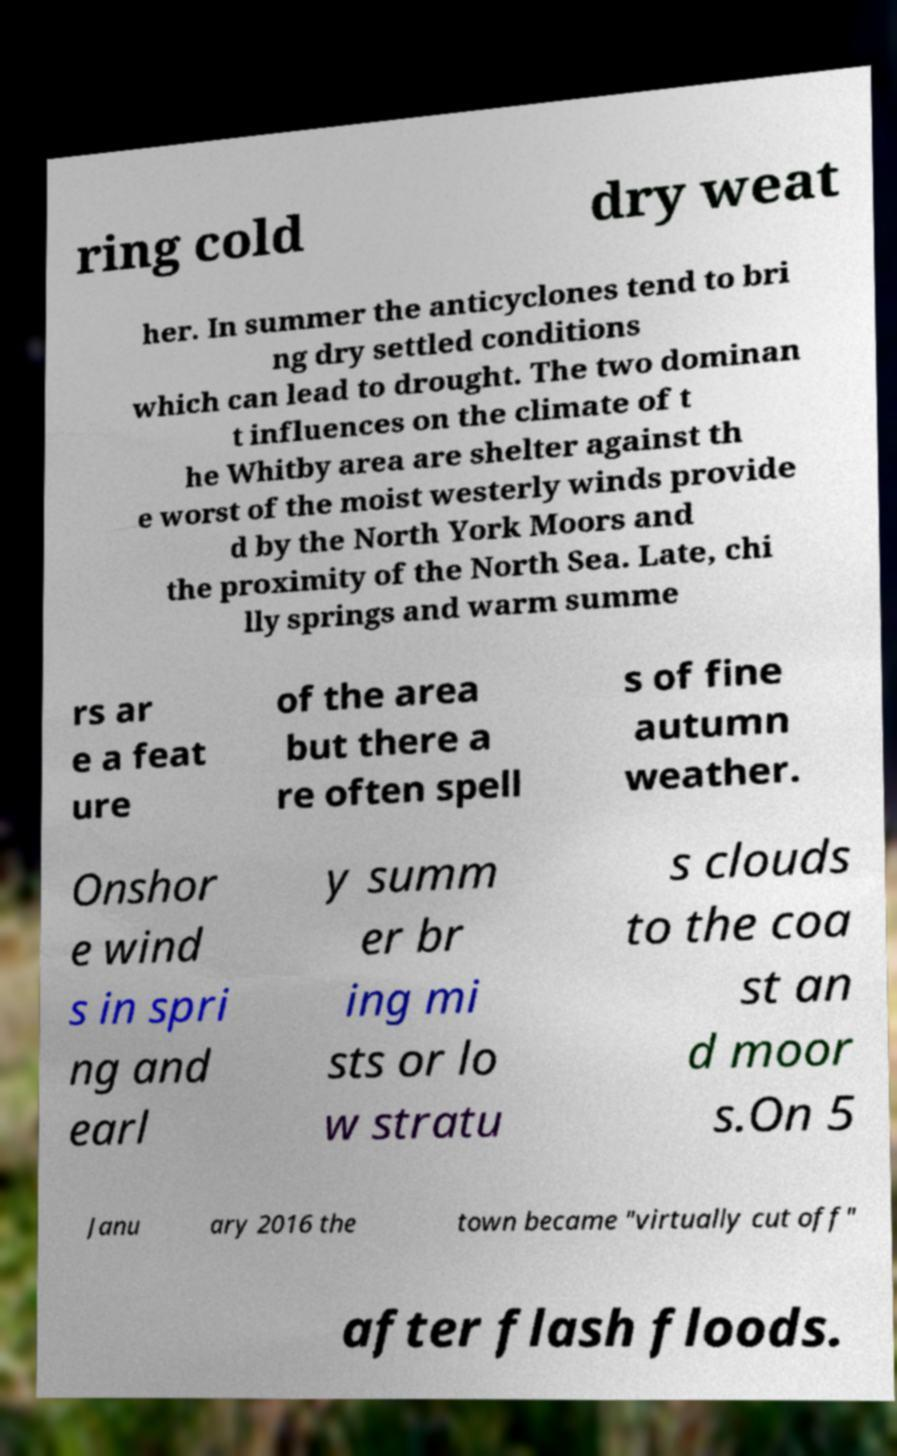I need the written content from this picture converted into text. Can you do that? ring cold dry weat her. In summer the anticyclones tend to bri ng dry settled conditions which can lead to drought. The two dominan t influences on the climate of t he Whitby area are shelter against th e worst of the moist westerly winds provide d by the North York Moors and the proximity of the North Sea. Late, chi lly springs and warm summe rs ar e a feat ure of the area but there a re often spell s of fine autumn weather. Onshor e wind s in spri ng and earl y summ er br ing mi sts or lo w stratu s clouds to the coa st an d moor s.On 5 Janu ary 2016 the town became "virtually cut off" after flash floods. 